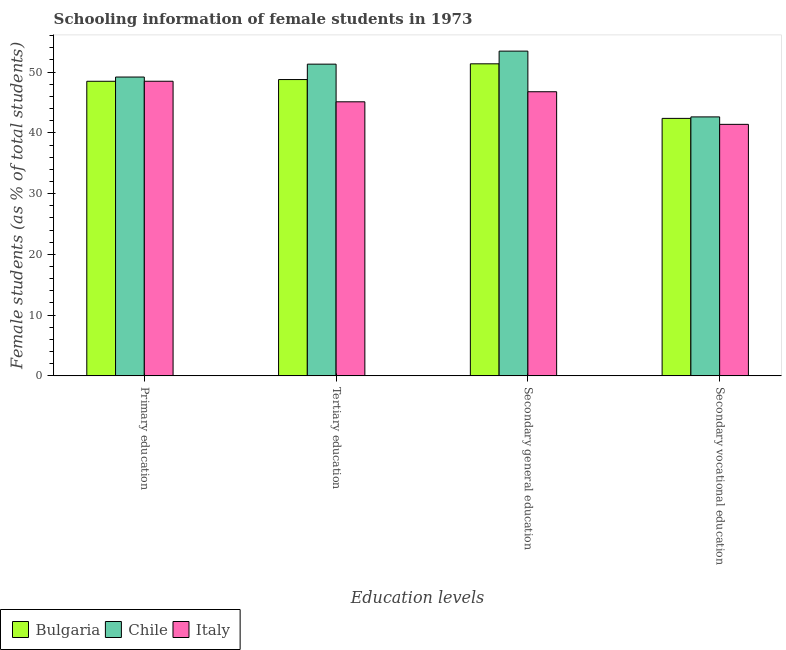How many groups of bars are there?
Give a very brief answer. 4. How many bars are there on the 1st tick from the left?
Your response must be concise. 3. How many bars are there on the 4th tick from the right?
Ensure brevity in your answer.  3. What is the label of the 3rd group of bars from the left?
Provide a succinct answer. Secondary general education. What is the percentage of female students in secondary vocational education in Bulgaria?
Keep it short and to the point. 42.38. Across all countries, what is the maximum percentage of female students in tertiary education?
Keep it short and to the point. 51.31. Across all countries, what is the minimum percentage of female students in primary education?
Provide a succinct answer. 48.49. What is the total percentage of female students in secondary education in the graph?
Your answer should be compact. 151.59. What is the difference between the percentage of female students in tertiary education in Bulgaria and that in Chile?
Your answer should be compact. -2.54. What is the difference between the percentage of female students in secondary education in Chile and the percentage of female students in secondary vocational education in Italy?
Your answer should be very brief. 12.06. What is the average percentage of female students in tertiary education per country?
Provide a short and direct response. 48.4. What is the difference between the percentage of female students in tertiary education and percentage of female students in secondary education in Bulgaria?
Give a very brief answer. -2.59. What is the ratio of the percentage of female students in secondary vocational education in Italy to that in Bulgaria?
Your answer should be compact. 0.98. What is the difference between the highest and the second highest percentage of female students in primary education?
Offer a very short reply. 0.69. What is the difference between the highest and the lowest percentage of female students in tertiary education?
Keep it short and to the point. 6.2. In how many countries, is the percentage of female students in tertiary education greater than the average percentage of female students in tertiary education taken over all countries?
Keep it short and to the point. 2. Is it the case that in every country, the sum of the percentage of female students in tertiary education and percentage of female students in primary education is greater than the sum of percentage of female students in secondary education and percentage of female students in secondary vocational education?
Keep it short and to the point. No. What does the 1st bar from the left in Secondary general education represents?
Provide a short and direct response. Bulgaria. What does the 2nd bar from the right in Secondary general education represents?
Offer a terse response. Chile. How many countries are there in the graph?
Your answer should be compact. 3. What is the difference between two consecutive major ticks on the Y-axis?
Offer a very short reply. 10. Does the graph contain any zero values?
Give a very brief answer. No. How many legend labels are there?
Keep it short and to the point. 3. What is the title of the graph?
Offer a very short reply. Schooling information of female students in 1973. What is the label or title of the X-axis?
Keep it short and to the point. Education levels. What is the label or title of the Y-axis?
Your answer should be compact. Female students (as % of total students). What is the Female students (as % of total students) of Bulgaria in Primary education?
Offer a very short reply. 48.49. What is the Female students (as % of total students) in Chile in Primary education?
Your answer should be very brief. 49.19. What is the Female students (as % of total students) of Italy in Primary education?
Provide a short and direct response. 48.5. What is the Female students (as % of total students) of Bulgaria in Tertiary education?
Your response must be concise. 48.77. What is the Female students (as % of total students) of Chile in Tertiary education?
Your response must be concise. 51.31. What is the Female students (as % of total students) in Italy in Tertiary education?
Your answer should be very brief. 45.11. What is the Female students (as % of total students) of Bulgaria in Secondary general education?
Make the answer very short. 51.36. What is the Female students (as % of total students) in Chile in Secondary general education?
Provide a succinct answer. 53.45. What is the Female students (as % of total students) of Italy in Secondary general education?
Offer a very short reply. 46.77. What is the Female students (as % of total students) of Bulgaria in Secondary vocational education?
Your response must be concise. 42.38. What is the Female students (as % of total students) in Chile in Secondary vocational education?
Ensure brevity in your answer.  42.63. What is the Female students (as % of total students) of Italy in Secondary vocational education?
Provide a short and direct response. 41.4. Across all Education levels, what is the maximum Female students (as % of total students) of Bulgaria?
Your answer should be very brief. 51.36. Across all Education levels, what is the maximum Female students (as % of total students) of Chile?
Keep it short and to the point. 53.45. Across all Education levels, what is the maximum Female students (as % of total students) in Italy?
Offer a very short reply. 48.5. Across all Education levels, what is the minimum Female students (as % of total students) in Bulgaria?
Your answer should be compact. 42.38. Across all Education levels, what is the minimum Female students (as % of total students) of Chile?
Offer a very short reply. 42.63. Across all Education levels, what is the minimum Female students (as % of total students) in Italy?
Make the answer very short. 41.4. What is the total Female students (as % of total students) in Bulgaria in the graph?
Your answer should be compact. 191.01. What is the total Female students (as % of total students) in Chile in the graph?
Give a very brief answer. 196.58. What is the total Female students (as % of total students) in Italy in the graph?
Ensure brevity in your answer.  181.77. What is the difference between the Female students (as % of total students) of Bulgaria in Primary education and that in Tertiary education?
Your response must be concise. -0.28. What is the difference between the Female students (as % of total students) of Chile in Primary education and that in Tertiary education?
Give a very brief answer. -2.12. What is the difference between the Female students (as % of total students) in Italy in Primary education and that in Tertiary education?
Your answer should be very brief. 3.39. What is the difference between the Female students (as % of total students) in Bulgaria in Primary education and that in Secondary general education?
Keep it short and to the point. -2.87. What is the difference between the Female students (as % of total students) in Chile in Primary education and that in Secondary general education?
Your response must be concise. -4.27. What is the difference between the Female students (as % of total students) of Italy in Primary education and that in Secondary general education?
Ensure brevity in your answer.  1.73. What is the difference between the Female students (as % of total students) of Bulgaria in Primary education and that in Secondary vocational education?
Your response must be concise. 6.11. What is the difference between the Female students (as % of total students) of Chile in Primary education and that in Secondary vocational education?
Give a very brief answer. 6.56. What is the difference between the Female students (as % of total students) in Italy in Primary education and that in Secondary vocational education?
Your answer should be very brief. 7.1. What is the difference between the Female students (as % of total students) of Bulgaria in Tertiary education and that in Secondary general education?
Offer a very short reply. -2.59. What is the difference between the Female students (as % of total students) of Chile in Tertiary education and that in Secondary general education?
Provide a succinct answer. -2.14. What is the difference between the Female students (as % of total students) of Italy in Tertiary education and that in Secondary general education?
Offer a very short reply. -1.66. What is the difference between the Female students (as % of total students) in Bulgaria in Tertiary education and that in Secondary vocational education?
Your response must be concise. 6.39. What is the difference between the Female students (as % of total students) of Chile in Tertiary education and that in Secondary vocational education?
Offer a terse response. 8.68. What is the difference between the Female students (as % of total students) in Italy in Tertiary education and that in Secondary vocational education?
Give a very brief answer. 3.71. What is the difference between the Female students (as % of total students) in Bulgaria in Secondary general education and that in Secondary vocational education?
Give a very brief answer. 8.98. What is the difference between the Female students (as % of total students) of Chile in Secondary general education and that in Secondary vocational education?
Your answer should be compact. 10.83. What is the difference between the Female students (as % of total students) in Italy in Secondary general education and that in Secondary vocational education?
Ensure brevity in your answer.  5.37. What is the difference between the Female students (as % of total students) of Bulgaria in Primary education and the Female students (as % of total students) of Chile in Tertiary education?
Make the answer very short. -2.82. What is the difference between the Female students (as % of total students) in Bulgaria in Primary education and the Female students (as % of total students) in Italy in Tertiary education?
Your answer should be very brief. 3.38. What is the difference between the Female students (as % of total students) in Chile in Primary education and the Female students (as % of total students) in Italy in Tertiary education?
Offer a terse response. 4.08. What is the difference between the Female students (as % of total students) of Bulgaria in Primary education and the Female students (as % of total students) of Chile in Secondary general education?
Offer a terse response. -4.96. What is the difference between the Female students (as % of total students) of Bulgaria in Primary education and the Female students (as % of total students) of Italy in Secondary general education?
Provide a succinct answer. 1.72. What is the difference between the Female students (as % of total students) in Chile in Primary education and the Female students (as % of total students) in Italy in Secondary general education?
Keep it short and to the point. 2.42. What is the difference between the Female students (as % of total students) of Bulgaria in Primary education and the Female students (as % of total students) of Chile in Secondary vocational education?
Give a very brief answer. 5.86. What is the difference between the Female students (as % of total students) of Bulgaria in Primary education and the Female students (as % of total students) of Italy in Secondary vocational education?
Ensure brevity in your answer.  7.09. What is the difference between the Female students (as % of total students) of Chile in Primary education and the Female students (as % of total students) of Italy in Secondary vocational education?
Offer a very short reply. 7.79. What is the difference between the Female students (as % of total students) of Bulgaria in Tertiary education and the Female students (as % of total students) of Chile in Secondary general education?
Make the answer very short. -4.68. What is the difference between the Female students (as % of total students) in Bulgaria in Tertiary education and the Female students (as % of total students) in Italy in Secondary general education?
Keep it short and to the point. 2.01. What is the difference between the Female students (as % of total students) in Chile in Tertiary education and the Female students (as % of total students) in Italy in Secondary general education?
Offer a terse response. 4.54. What is the difference between the Female students (as % of total students) of Bulgaria in Tertiary education and the Female students (as % of total students) of Chile in Secondary vocational education?
Your answer should be compact. 6.15. What is the difference between the Female students (as % of total students) in Bulgaria in Tertiary education and the Female students (as % of total students) in Italy in Secondary vocational education?
Give a very brief answer. 7.38. What is the difference between the Female students (as % of total students) in Chile in Tertiary education and the Female students (as % of total students) in Italy in Secondary vocational education?
Give a very brief answer. 9.91. What is the difference between the Female students (as % of total students) of Bulgaria in Secondary general education and the Female students (as % of total students) of Chile in Secondary vocational education?
Offer a terse response. 8.74. What is the difference between the Female students (as % of total students) of Bulgaria in Secondary general education and the Female students (as % of total students) of Italy in Secondary vocational education?
Your answer should be very brief. 9.96. What is the difference between the Female students (as % of total students) in Chile in Secondary general education and the Female students (as % of total students) in Italy in Secondary vocational education?
Offer a very short reply. 12.06. What is the average Female students (as % of total students) in Bulgaria per Education levels?
Keep it short and to the point. 47.75. What is the average Female students (as % of total students) of Chile per Education levels?
Ensure brevity in your answer.  49.14. What is the average Female students (as % of total students) in Italy per Education levels?
Offer a terse response. 45.44. What is the difference between the Female students (as % of total students) in Bulgaria and Female students (as % of total students) in Chile in Primary education?
Offer a terse response. -0.7. What is the difference between the Female students (as % of total students) of Bulgaria and Female students (as % of total students) of Italy in Primary education?
Provide a succinct answer. -0.01. What is the difference between the Female students (as % of total students) in Chile and Female students (as % of total students) in Italy in Primary education?
Keep it short and to the point. 0.69. What is the difference between the Female students (as % of total students) in Bulgaria and Female students (as % of total students) in Chile in Tertiary education?
Offer a terse response. -2.54. What is the difference between the Female students (as % of total students) in Bulgaria and Female students (as % of total students) in Italy in Tertiary education?
Your answer should be compact. 3.66. What is the difference between the Female students (as % of total students) of Chile and Female students (as % of total students) of Italy in Tertiary education?
Offer a terse response. 6.2. What is the difference between the Female students (as % of total students) in Bulgaria and Female students (as % of total students) in Chile in Secondary general education?
Provide a succinct answer. -2.09. What is the difference between the Female students (as % of total students) of Bulgaria and Female students (as % of total students) of Italy in Secondary general education?
Give a very brief answer. 4.6. What is the difference between the Female students (as % of total students) in Chile and Female students (as % of total students) in Italy in Secondary general education?
Make the answer very short. 6.69. What is the difference between the Female students (as % of total students) of Bulgaria and Female students (as % of total students) of Chile in Secondary vocational education?
Provide a succinct answer. -0.24. What is the difference between the Female students (as % of total students) of Bulgaria and Female students (as % of total students) of Italy in Secondary vocational education?
Ensure brevity in your answer.  0.98. What is the difference between the Female students (as % of total students) in Chile and Female students (as % of total students) in Italy in Secondary vocational education?
Provide a succinct answer. 1.23. What is the ratio of the Female students (as % of total students) in Chile in Primary education to that in Tertiary education?
Give a very brief answer. 0.96. What is the ratio of the Female students (as % of total students) of Italy in Primary education to that in Tertiary education?
Make the answer very short. 1.08. What is the ratio of the Female students (as % of total students) in Bulgaria in Primary education to that in Secondary general education?
Make the answer very short. 0.94. What is the ratio of the Female students (as % of total students) of Chile in Primary education to that in Secondary general education?
Your answer should be very brief. 0.92. What is the ratio of the Female students (as % of total students) in Bulgaria in Primary education to that in Secondary vocational education?
Offer a terse response. 1.14. What is the ratio of the Female students (as % of total students) of Chile in Primary education to that in Secondary vocational education?
Ensure brevity in your answer.  1.15. What is the ratio of the Female students (as % of total students) in Italy in Primary education to that in Secondary vocational education?
Give a very brief answer. 1.17. What is the ratio of the Female students (as % of total students) in Bulgaria in Tertiary education to that in Secondary general education?
Provide a succinct answer. 0.95. What is the ratio of the Female students (as % of total students) in Chile in Tertiary education to that in Secondary general education?
Offer a terse response. 0.96. What is the ratio of the Female students (as % of total students) in Italy in Tertiary education to that in Secondary general education?
Provide a succinct answer. 0.96. What is the ratio of the Female students (as % of total students) of Bulgaria in Tertiary education to that in Secondary vocational education?
Your answer should be compact. 1.15. What is the ratio of the Female students (as % of total students) of Chile in Tertiary education to that in Secondary vocational education?
Keep it short and to the point. 1.2. What is the ratio of the Female students (as % of total students) in Italy in Tertiary education to that in Secondary vocational education?
Provide a short and direct response. 1.09. What is the ratio of the Female students (as % of total students) in Bulgaria in Secondary general education to that in Secondary vocational education?
Your answer should be compact. 1.21. What is the ratio of the Female students (as % of total students) in Chile in Secondary general education to that in Secondary vocational education?
Your answer should be compact. 1.25. What is the ratio of the Female students (as % of total students) in Italy in Secondary general education to that in Secondary vocational education?
Provide a short and direct response. 1.13. What is the difference between the highest and the second highest Female students (as % of total students) of Bulgaria?
Provide a short and direct response. 2.59. What is the difference between the highest and the second highest Female students (as % of total students) in Chile?
Keep it short and to the point. 2.14. What is the difference between the highest and the second highest Female students (as % of total students) in Italy?
Provide a short and direct response. 1.73. What is the difference between the highest and the lowest Female students (as % of total students) of Bulgaria?
Your response must be concise. 8.98. What is the difference between the highest and the lowest Female students (as % of total students) in Chile?
Give a very brief answer. 10.83. What is the difference between the highest and the lowest Female students (as % of total students) in Italy?
Keep it short and to the point. 7.1. 